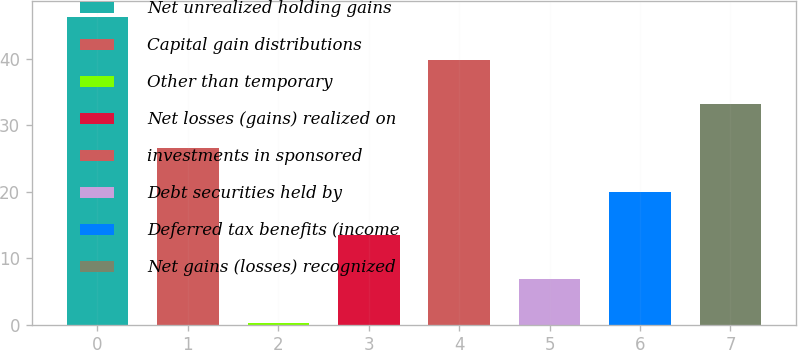Convert chart to OTSL. <chart><loc_0><loc_0><loc_500><loc_500><bar_chart><fcel>Net unrealized holding gains<fcel>Capital gain distributions<fcel>Other than temporary<fcel>Net losses (gains) realized on<fcel>investments in sponsored<fcel>Debt securities held by<fcel>Deferred tax benefits (income<fcel>Net gains (losses) recognized<nl><fcel>46.29<fcel>26.58<fcel>0.3<fcel>13.44<fcel>39.72<fcel>6.87<fcel>20.01<fcel>33.15<nl></chart> 